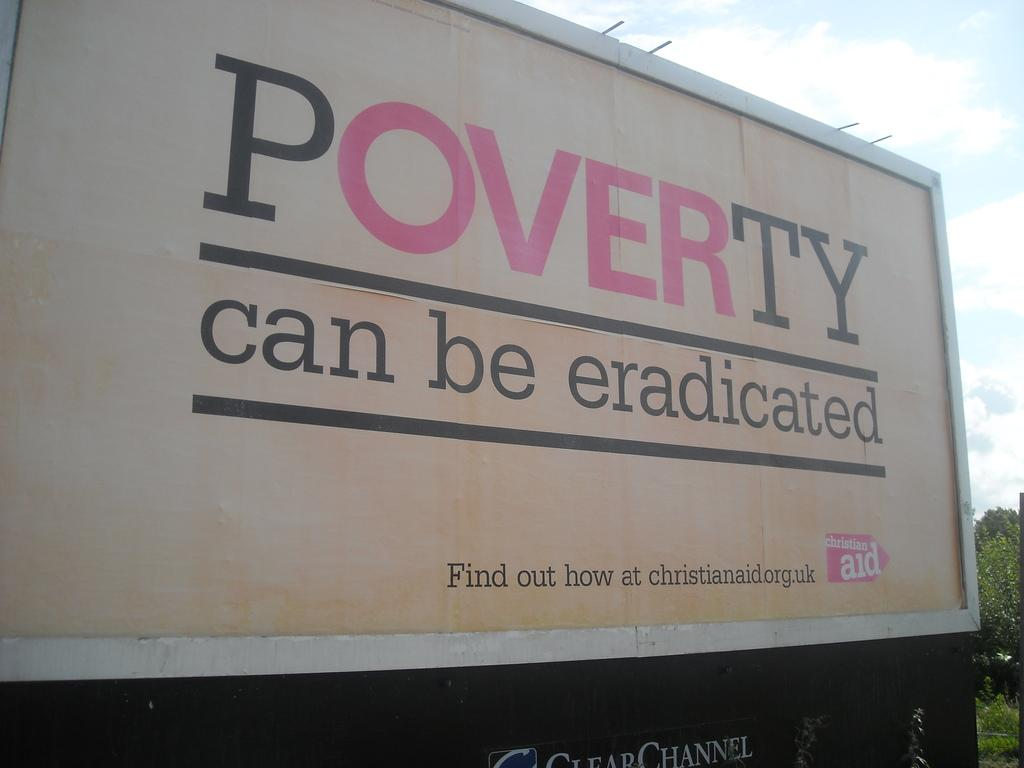<image>
Give a short and clear explanation of the subsequent image. The side of a truck is advocating against poverty. 